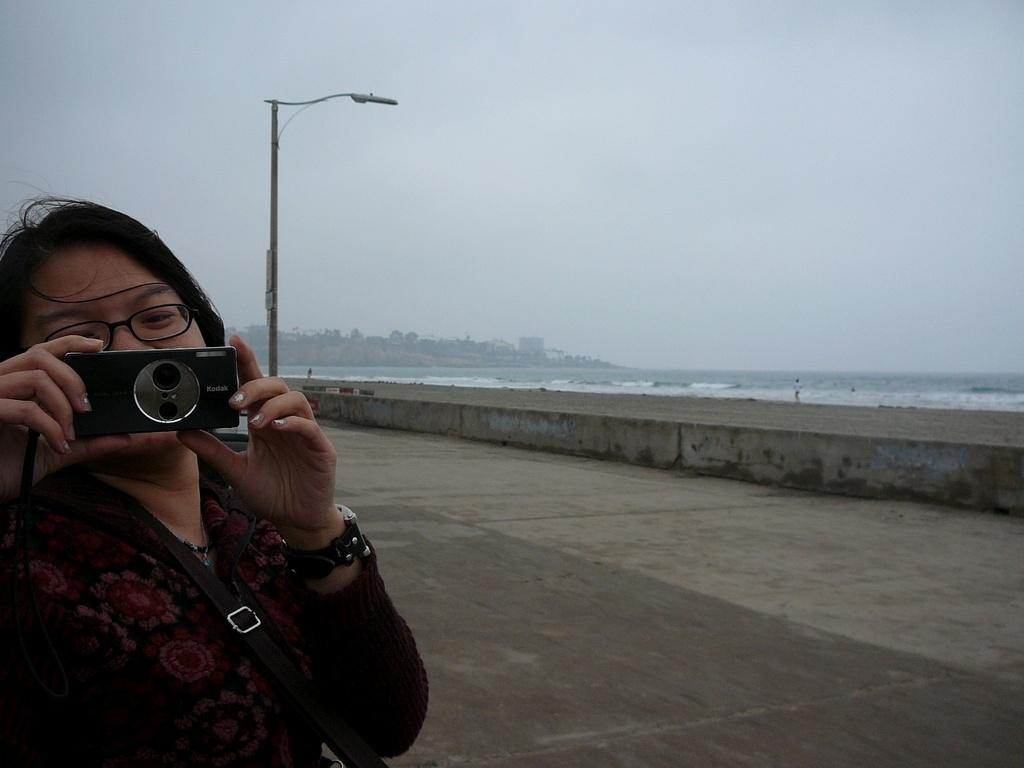What is the condition of the sky in the image? The sky is clear in the image. What can be seen in the image besides the sky? There is water visible in the image, as well as a street lamp. What is the woman in the image doing? The woman is holding a camera in the image. What type of glue is the woman using to attach the shock to her heart in the image? There is no glue, shock, or heart present in the image. The woman is simply holding a camera. 